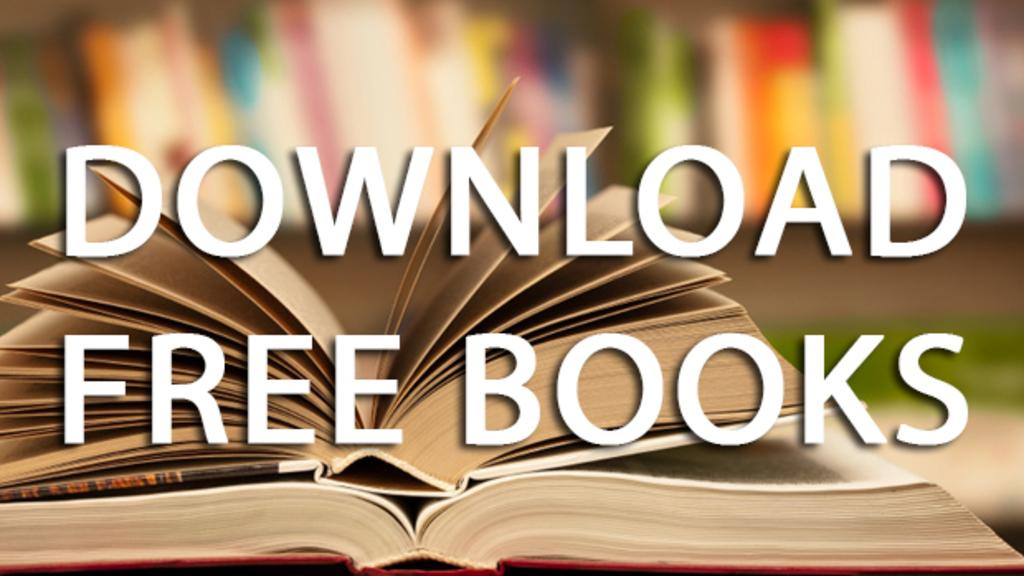<image>
Relay a brief, clear account of the picture shown. An ad for learning how to download free books. 